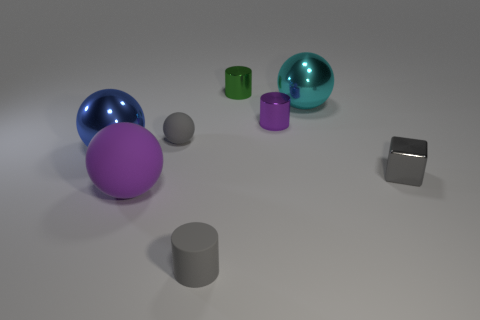How many purple objects are both behind the big purple matte thing and on the left side of the small gray sphere?
Keep it short and to the point. 0. How many gray objects are small blocks or small rubber cylinders?
Provide a short and direct response. 2. There is a ball right of the green cylinder; does it have the same color as the large metal sphere on the left side of the small sphere?
Provide a succinct answer. No. What is the color of the metallic sphere behind the tiny gray matte thing behind the gray object that is right of the big cyan shiny thing?
Your response must be concise. Cyan. There is a metallic cylinder behind the large cyan ball; is there a metal cylinder that is in front of it?
Keep it short and to the point. Yes. There is a purple thing that is on the right side of the tiny gray cylinder; does it have the same shape as the purple rubber object?
Your response must be concise. No. Are there any other things that are the same shape as the big purple rubber object?
Offer a terse response. Yes. How many cylinders are either tiny purple shiny objects or blue objects?
Your answer should be compact. 1. How many matte balls are there?
Your response must be concise. 2. There is a blue sphere that is left of the small cylinder that is in front of the large purple rubber thing; how big is it?
Offer a terse response. Large. 